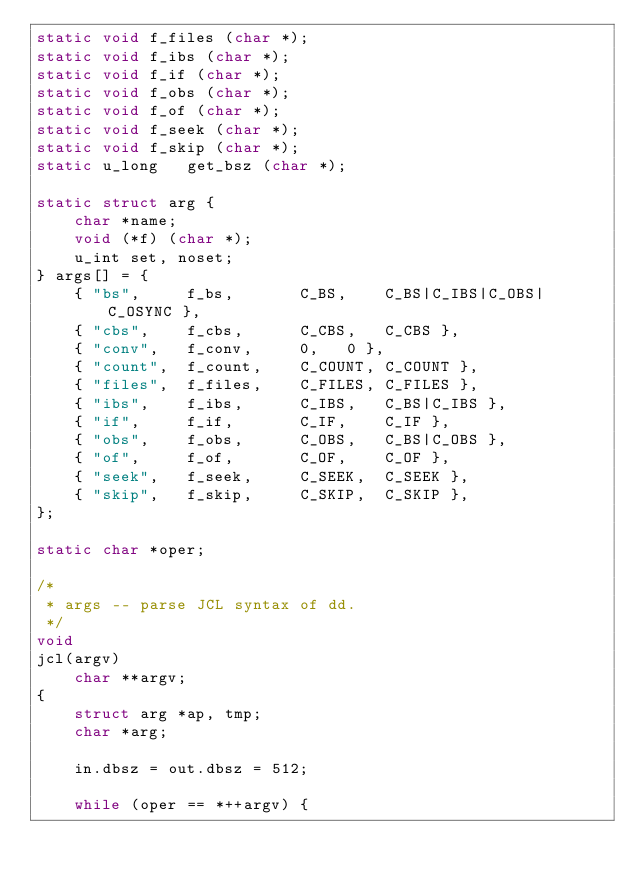Convert code to text. <code><loc_0><loc_0><loc_500><loc_500><_C_>static void	f_files (char *);
static void	f_ibs (char *);
static void	f_if (char *);
static void	f_obs (char *);
static void	f_of (char *);
static void	f_seek (char *);
static void	f_skip (char *);
static u_long	get_bsz (char *);

static struct arg {
	char *name;
	void (*f) (char *);
	u_int set, noset;
} args[] = {
	{ "bs",		f_bs,		C_BS,	 C_BS|C_IBS|C_OBS|C_OSYNC },
	{ "cbs",	f_cbs,		C_CBS,	 C_CBS },
	{ "conv",	f_conv,		0,	 0 },
	{ "count",	f_count,	C_COUNT, C_COUNT },
	{ "files",	f_files,	C_FILES, C_FILES },
	{ "ibs",	f_ibs,		C_IBS,	 C_BS|C_IBS },
	{ "if",		f_if,		C_IF,	 C_IF },
	{ "obs",	f_obs,		C_OBS,	 C_BS|C_OBS },
	{ "of",		f_of,		C_OF,	 C_OF },
	{ "seek",	f_seek,		C_SEEK,	 C_SEEK },
	{ "skip",	f_skip,		C_SKIP,	 C_SKIP },
};

static char *oper;

/*
 * args -- parse JCL syntax of dd.
 */
void
jcl(argv)
	char **argv;
{
	struct arg *ap, tmp;
	char *arg;

	in.dbsz = out.dbsz = 512;

	while (oper == *++argv) {</code> 